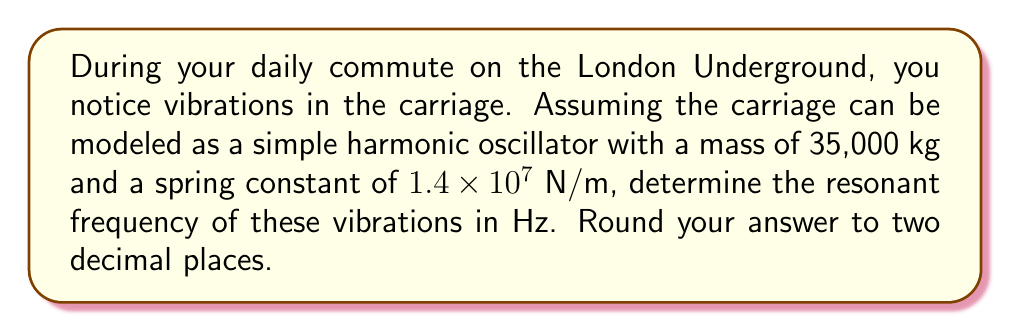Can you answer this question? To solve this problem, we'll use the formula for the resonant frequency of a simple harmonic oscillator:

$$f = \frac{1}{2\pi}\sqrt{\frac{k}{m}}$$

Where:
$f$ is the resonant frequency in Hz
$k$ is the spring constant in N/m
$m$ is the mass in kg

Given:
$k = 1.4 \times 10^7$ N/m
$m = 35,000$ kg

Step 1: Substitute the values into the formula:

$$f = \frac{1}{2\pi}\sqrt{\frac{1.4 \times 10^7}{35,000}}$$

Step 2: Simplify inside the square root:

$$f = \frac{1}{2\pi}\sqrt{400}$$

Step 3: Calculate the square root:

$$f = \frac{1}{2\pi} \times 20$$

Step 4: Compute the final result:

$$f = \frac{20}{2\pi} \approx 3.1831 \text{ Hz}$$

Step 5: Round to two decimal places:

$$f \approx 3.18 \text{ Hz}$$
Answer: $3.18 \text{ Hz}$ 